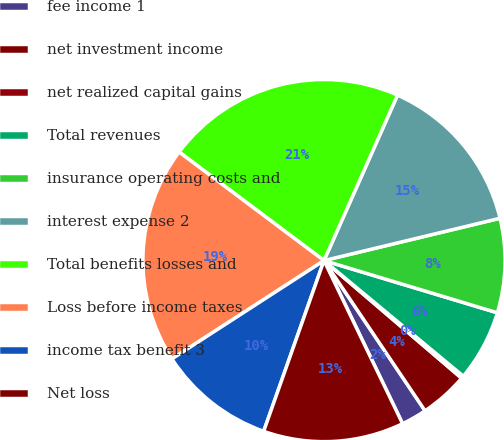Convert chart to OTSL. <chart><loc_0><loc_0><loc_500><loc_500><pie_chart><fcel>fee income 1<fcel>net investment income<fcel>net realized capital gains<fcel>Total revenues<fcel>insurance operating costs and<fcel>interest expense 2<fcel>Total benefits losses and<fcel>Loss before income taxes<fcel>income tax benefit 3<fcel>Net loss<nl><fcel>2.28%<fcel>4.32%<fcel>0.23%<fcel>6.37%<fcel>8.41%<fcel>14.59%<fcel>21.42%<fcel>19.37%<fcel>10.46%<fcel>12.55%<nl></chart> 